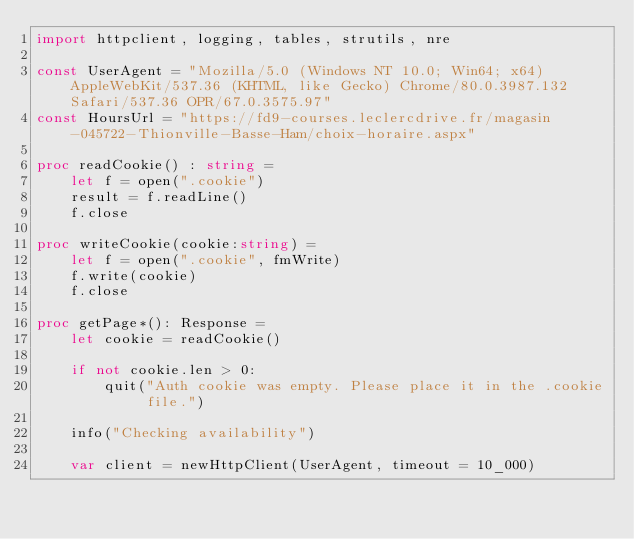<code> <loc_0><loc_0><loc_500><loc_500><_Nim_>import httpclient, logging, tables, strutils, nre

const UserAgent = "Mozilla/5.0 (Windows NT 10.0; Win64; x64) AppleWebKit/537.36 (KHTML, like Gecko) Chrome/80.0.3987.132 Safari/537.36 OPR/67.0.3575.97"
const HoursUrl = "https://fd9-courses.leclercdrive.fr/magasin-045722-Thionville-Basse-Ham/choix-horaire.aspx" 

proc readCookie() : string =
    let f = open(".cookie")
    result = f.readLine()
    f.close

proc writeCookie(cookie:string) =
    let f = open(".cookie", fmWrite)
    f.write(cookie)
    f.close

proc getPage*(): Response =
    let cookie = readCookie()
    
    if not cookie.len > 0:
        quit("Auth cookie was empty. Please place it in the .cookie file.")

    info("Checking availability")

    var client = newHttpClient(UserAgent, timeout = 10_000)
</code> 